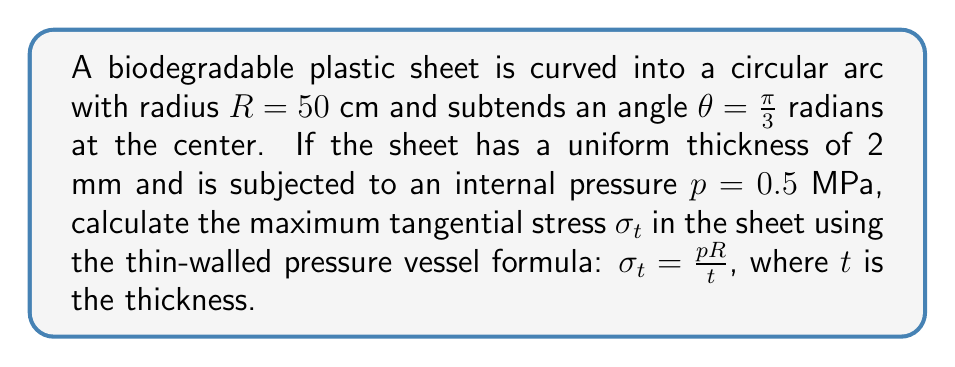Help me with this question. To solve this problem, we'll follow these steps:

1) First, let's identify the given values:
   $R = 50$ cm = 0.5 m
   $t = 2$ mm = 0.002 m
   $p = 0.5$ MPa = 500,000 Pa

2) We can directly apply the thin-walled pressure vessel formula:

   $$\sigma_t = \frac{pR}{t}$$

3) Substitute the values:

   $$\sigma_t = \frac{500,000 \text{ Pa} \times 0.5 \text{ m}}{0.002 \text{ m}}$$

4) Perform the calculation:

   $$\sigma_t = \frac{250,000}{0.002} = 125,000,000 \text{ Pa}$$

5) Convert the result to MPa for a more manageable number:

   $$\sigma_t = 125 \text{ MPa}$$

Thus, the maximum tangential stress in the biodegradable plastic sheet is 125 MPa.
Answer: 125 MPa 